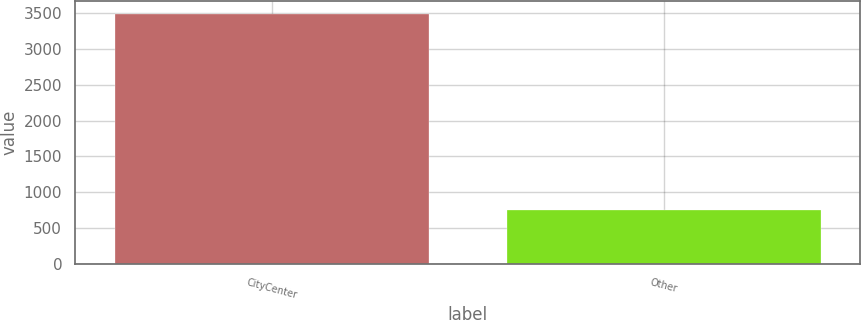Convert chart to OTSL. <chart><loc_0><loc_0><loc_500><loc_500><bar_chart><fcel>CityCenter<fcel>Other<nl><fcel>3494<fcel>753<nl></chart> 